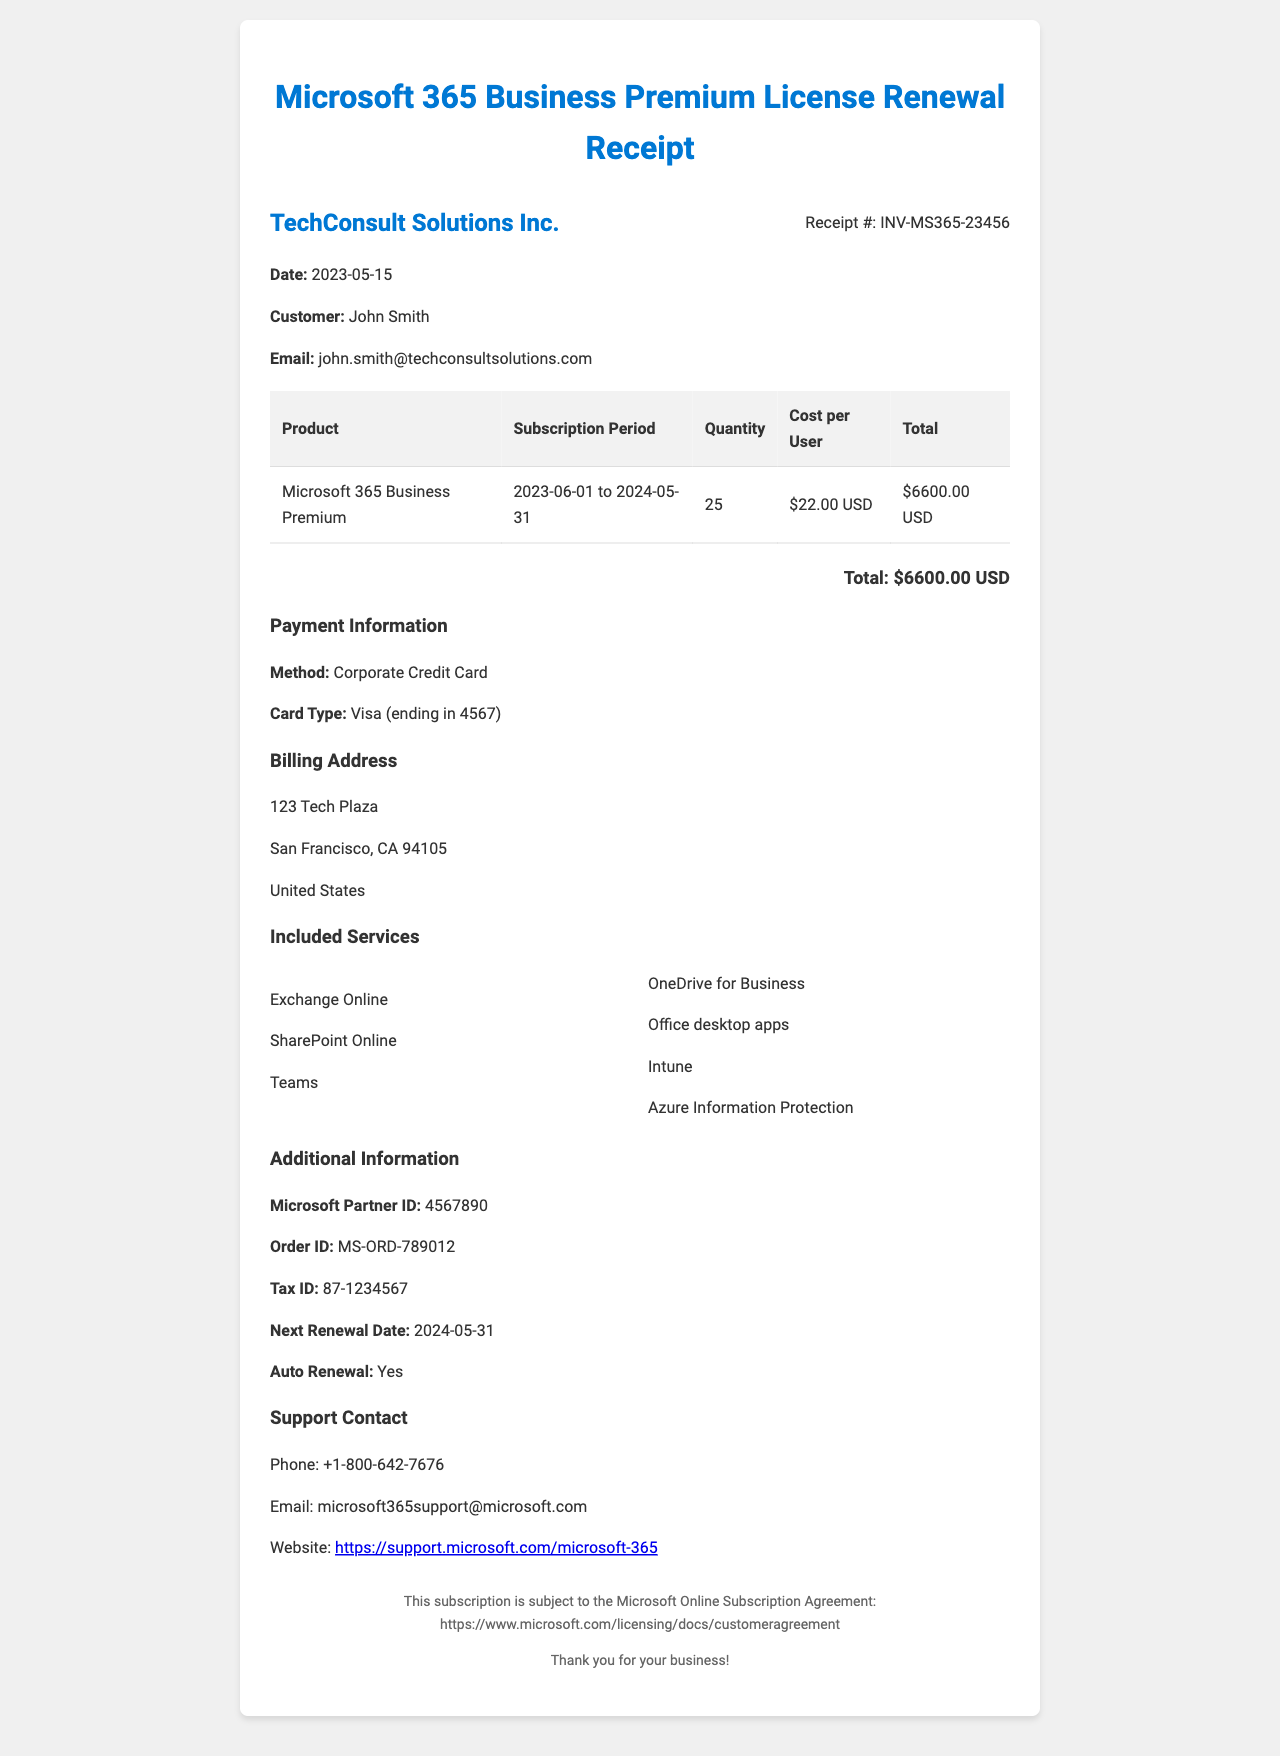What is the receipt number? The receipt number is a unique identifier for this transaction, which is listed in the document.
Answer: INV-MS365-23456 What is the subscription period? The subscription period is indicated by the start and end dates shown in the document.
Answer: June 1, 2023 to May 31, 2024 How many licenses were purchased? The number of licenses purchased is specified in the document.
Answer: 25 What is the cost per user? The cost per user is indicated in the pricing section of the receipt.
Answer: $22.00 USD What is the total cost? The total cost is the overall amount billed for the subscription, which is detailed in the document.
Answer: $6600.00 USD Who is the customer? The customer name is stated prominently within the receipt details.
Answer: John Smith What is the payment method? The payment method used for the transaction is mentioned in the payment information section.
Answer: Corporate Credit Card What are included services? The included services are listed in a dedicated section of the document.
Answer: Exchange Online, SharePoint Online, Teams, OneDrive for Business, Office desktop apps, Intune, Azure Information Protection When is the next renewal date? The next renewal date is provided in the additional information section of the receipt.
Answer: May 31, 2024 